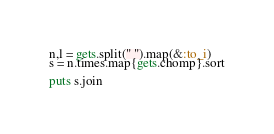<code> <loc_0><loc_0><loc_500><loc_500><_Ruby_>n,l = gets.split(" ").map(&:to_i)
s = n.times.map{gets.chomp}.sort
 
puts s.join</code> 